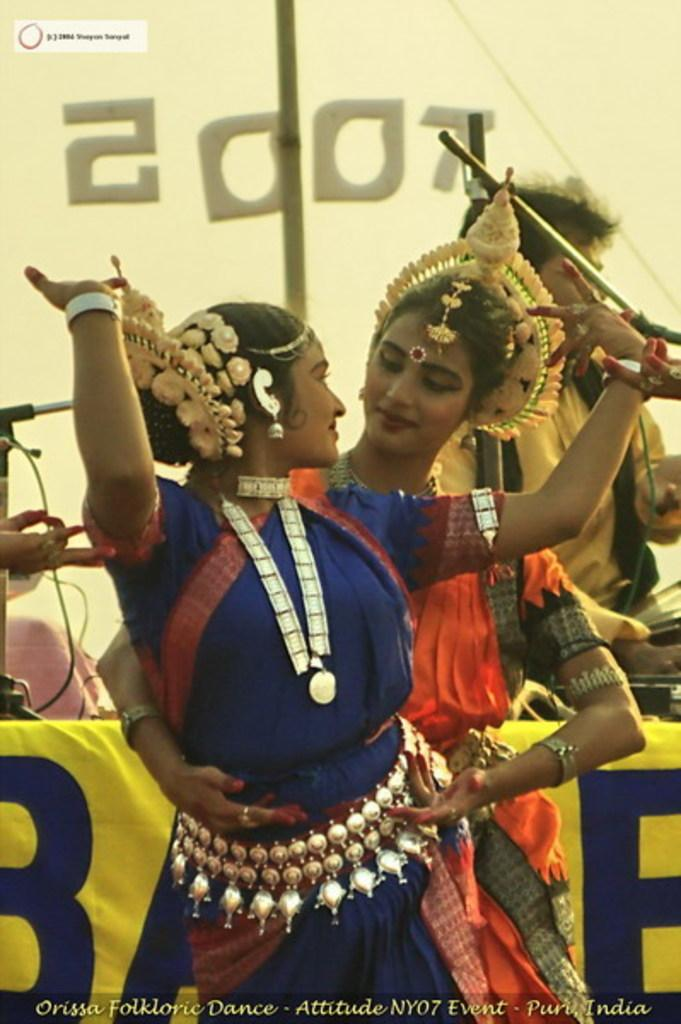How many people are in the image? There are three people in the image. What is the gender of the people in the image? Two of the people are women. What are the two women doing in the image? The two women are dancing. What type of sticks are the women using to dance in the image? There are no sticks present in the image; the women are dancing without any props. 